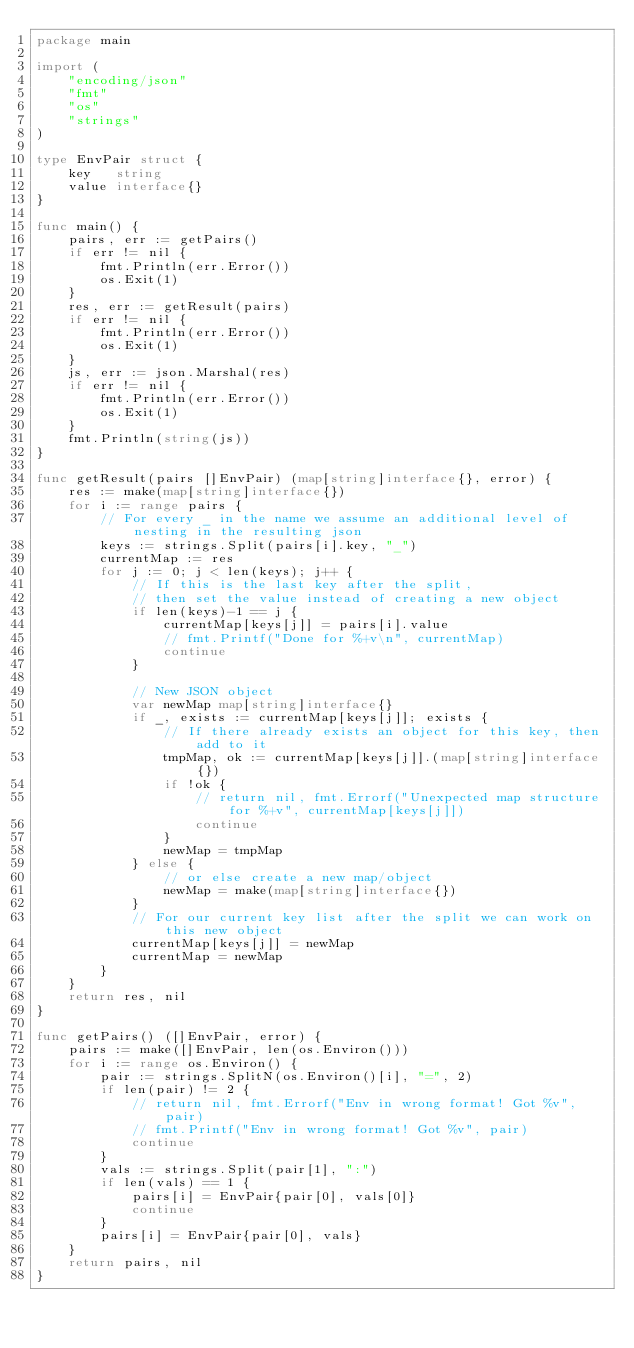Convert code to text. <code><loc_0><loc_0><loc_500><loc_500><_Go_>package main

import (
	"encoding/json"
	"fmt"
	"os"
	"strings"
)

type EnvPair struct {
	key   string
	value interface{}
}

func main() {
	pairs, err := getPairs()
	if err != nil {
		fmt.Println(err.Error())
		os.Exit(1)
	}
	res, err := getResult(pairs)
	if err != nil {
		fmt.Println(err.Error())
		os.Exit(1)
	}
	js, err := json.Marshal(res)
	if err != nil {
		fmt.Println(err.Error())
		os.Exit(1)
	}
	fmt.Println(string(js))
}

func getResult(pairs []EnvPair) (map[string]interface{}, error) {
	res := make(map[string]interface{})
	for i := range pairs {
		// For every _ in the name we assume an additional level of nesting in the resulting json
		keys := strings.Split(pairs[i].key, "_")
		currentMap := res
		for j := 0; j < len(keys); j++ {
			// If this is the last key after the split,
			// then set the value instead of creating a new object
			if len(keys)-1 == j {
				currentMap[keys[j]] = pairs[i].value
				// fmt.Printf("Done for %+v\n", currentMap)
				continue
			}

			// New JSON object
			var newMap map[string]interface{}
			if _, exists := currentMap[keys[j]]; exists {
				// If there already exists an object for this key, then add to it
				tmpMap, ok := currentMap[keys[j]].(map[string]interface{})
				if !ok {
					// return nil, fmt.Errorf("Unexpected map structure for %+v", currentMap[keys[j]])
					continue
				}
				newMap = tmpMap
			} else {
				// or else create a new map/object
				newMap = make(map[string]interface{})
			}
			// For our current key list after the split we can work on this new object
			currentMap[keys[j]] = newMap
			currentMap = newMap
		}
	}
	return res, nil
}

func getPairs() ([]EnvPair, error) {
	pairs := make([]EnvPair, len(os.Environ()))
	for i := range os.Environ() {
		pair := strings.SplitN(os.Environ()[i], "=", 2)
		if len(pair) != 2 {
			// return nil, fmt.Errorf("Env in wrong format! Got %v", pair)
			// fmt.Printf("Env in wrong format! Got %v", pair)
			continue
		}
		vals := strings.Split(pair[1], ":")
		if len(vals) == 1 {
			pairs[i] = EnvPair{pair[0], vals[0]}
			continue
		}
		pairs[i] = EnvPair{pair[0], vals}
	}
	return pairs, nil
}
</code> 